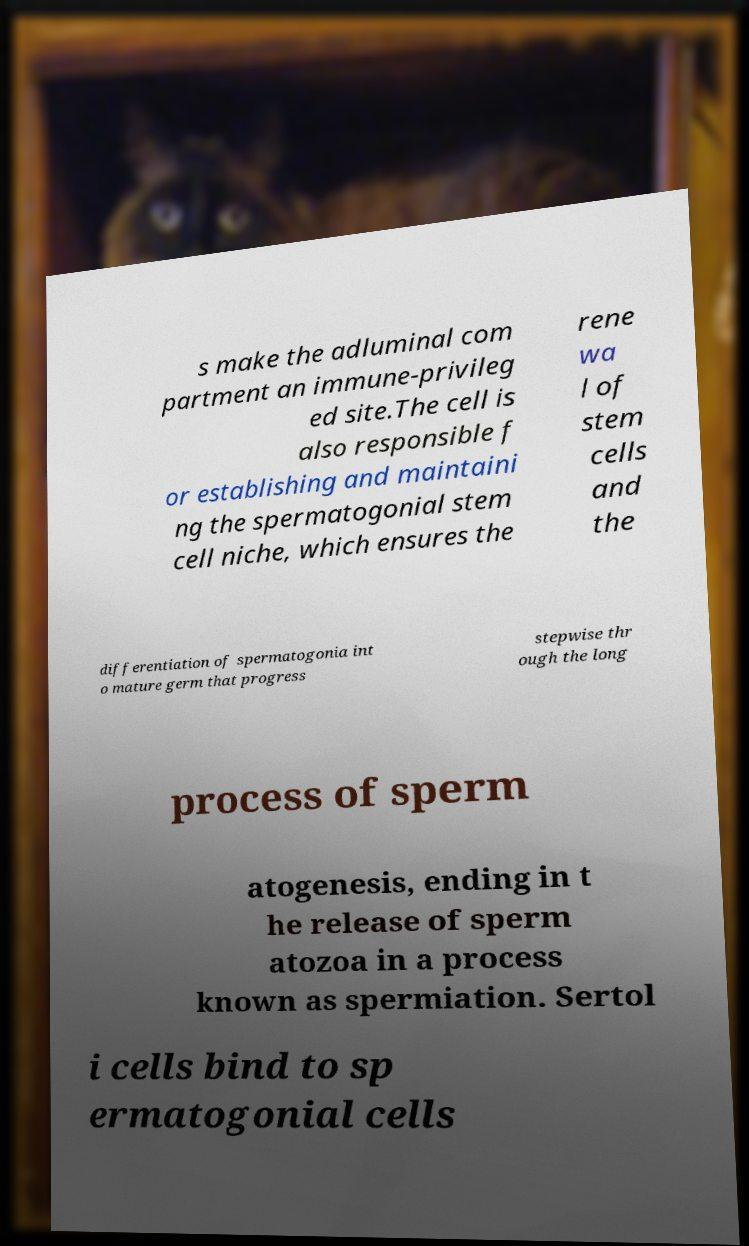Can you accurately transcribe the text from the provided image for me? s make the adluminal com partment an immune-privileg ed site.The cell is also responsible f or establishing and maintaini ng the spermatogonial stem cell niche, which ensures the rene wa l of stem cells and the differentiation of spermatogonia int o mature germ that progress stepwise thr ough the long process of sperm atogenesis, ending in t he release of sperm atozoa in a process known as spermiation. Sertol i cells bind to sp ermatogonial cells 